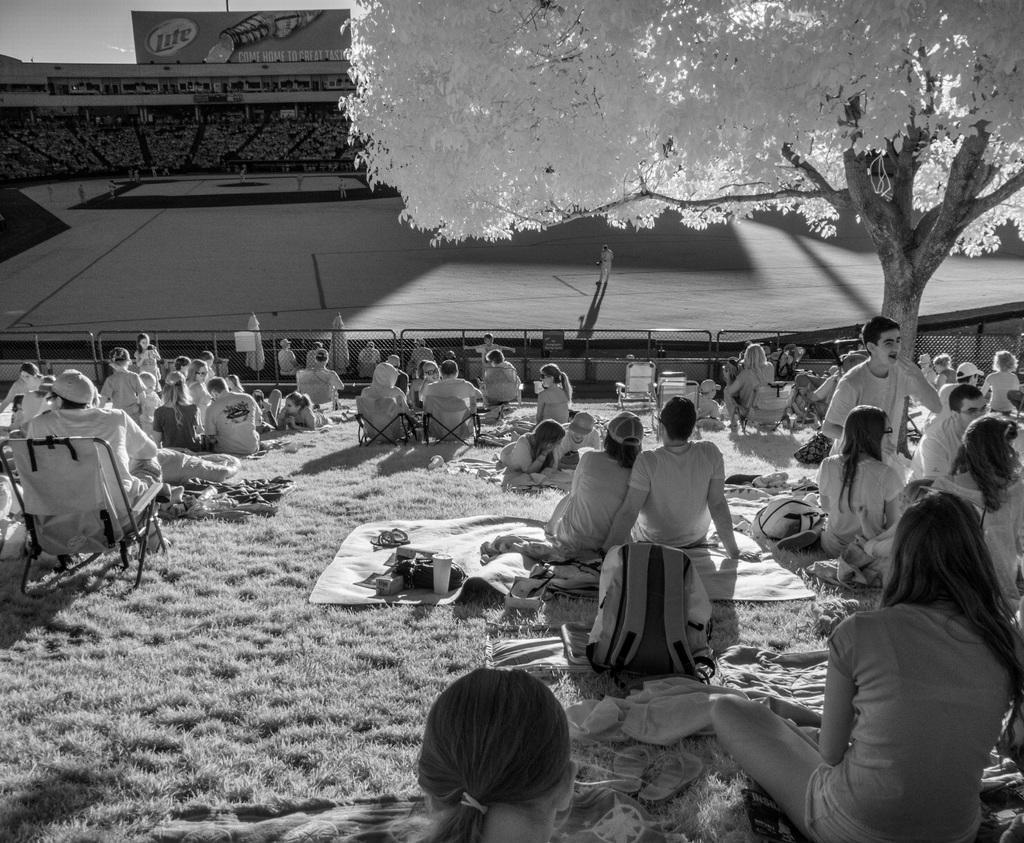How would you summarize this image in a sentence or two? In this image there are group of persons sitting and laying. In the background there is a stadium and there are persons standing and there is a banner with some text written on it. On the right side there is a tree. 